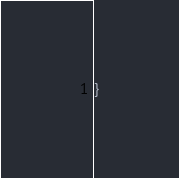<code> <loc_0><loc_0><loc_500><loc_500><_Java_>}
</code> 